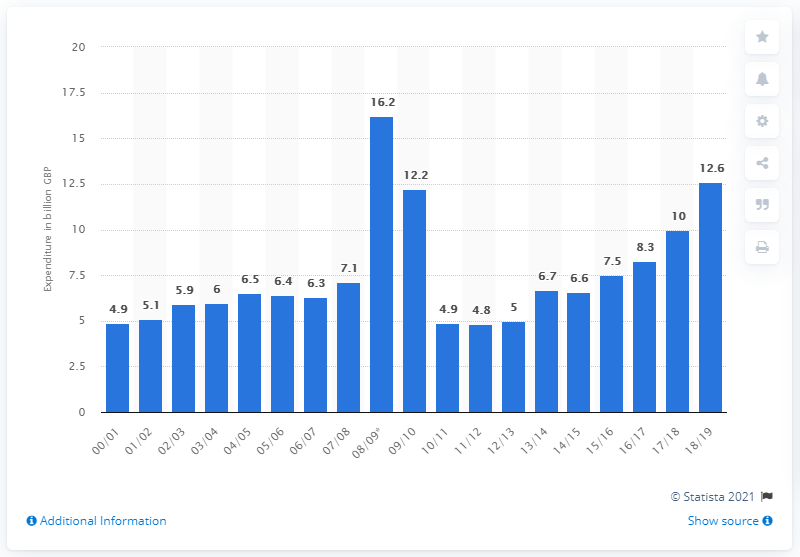Outline some significant characteristics in this image. In the 2008/09 fiscal year, the peak amount of public sector expenditure on enterprise and economic development was 16.2 billion US dollars. 